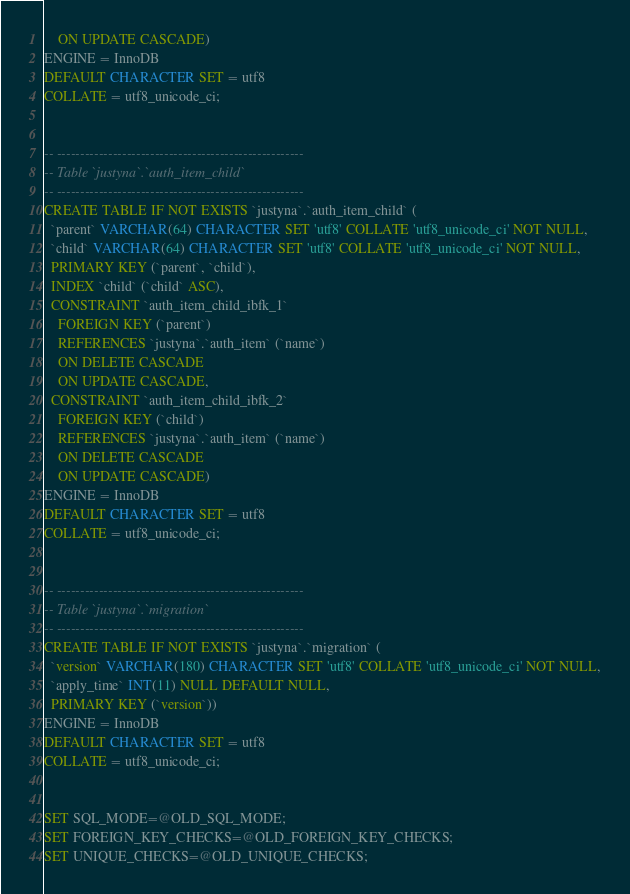<code> <loc_0><loc_0><loc_500><loc_500><_SQL_>    ON UPDATE CASCADE)
ENGINE = InnoDB
DEFAULT CHARACTER SET = utf8
COLLATE = utf8_unicode_ci;


-- -----------------------------------------------------
-- Table `justyna`.`auth_item_child`
-- -----------------------------------------------------
CREATE TABLE IF NOT EXISTS `justyna`.`auth_item_child` (
  `parent` VARCHAR(64) CHARACTER SET 'utf8' COLLATE 'utf8_unicode_ci' NOT NULL,
  `child` VARCHAR(64) CHARACTER SET 'utf8' COLLATE 'utf8_unicode_ci' NOT NULL,
  PRIMARY KEY (`parent`, `child`),
  INDEX `child` (`child` ASC),
  CONSTRAINT `auth_item_child_ibfk_1`
    FOREIGN KEY (`parent`)
    REFERENCES `justyna`.`auth_item` (`name`)
    ON DELETE CASCADE
    ON UPDATE CASCADE,
  CONSTRAINT `auth_item_child_ibfk_2`
    FOREIGN KEY (`child`)
    REFERENCES `justyna`.`auth_item` (`name`)
    ON DELETE CASCADE
    ON UPDATE CASCADE)
ENGINE = InnoDB
DEFAULT CHARACTER SET = utf8
COLLATE = utf8_unicode_ci;


-- -----------------------------------------------------
-- Table `justyna`.`migration`
-- -----------------------------------------------------
CREATE TABLE IF NOT EXISTS `justyna`.`migration` (
  `version` VARCHAR(180) CHARACTER SET 'utf8' COLLATE 'utf8_unicode_ci' NOT NULL,
  `apply_time` INT(11) NULL DEFAULT NULL,
  PRIMARY KEY (`version`))
ENGINE = InnoDB
DEFAULT CHARACTER SET = utf8
COLLATE = utf8_unicode_ci;


SET SQL_MODE=@OLD_SQL_MODE;
SET FOREIGN_KEY_CHECKS=@OLD_FOREIGN_KEY_CHECKS;
SET UNIQUE_CHECKS=@OLD_UNIQUE_CHECKS;
</code> 